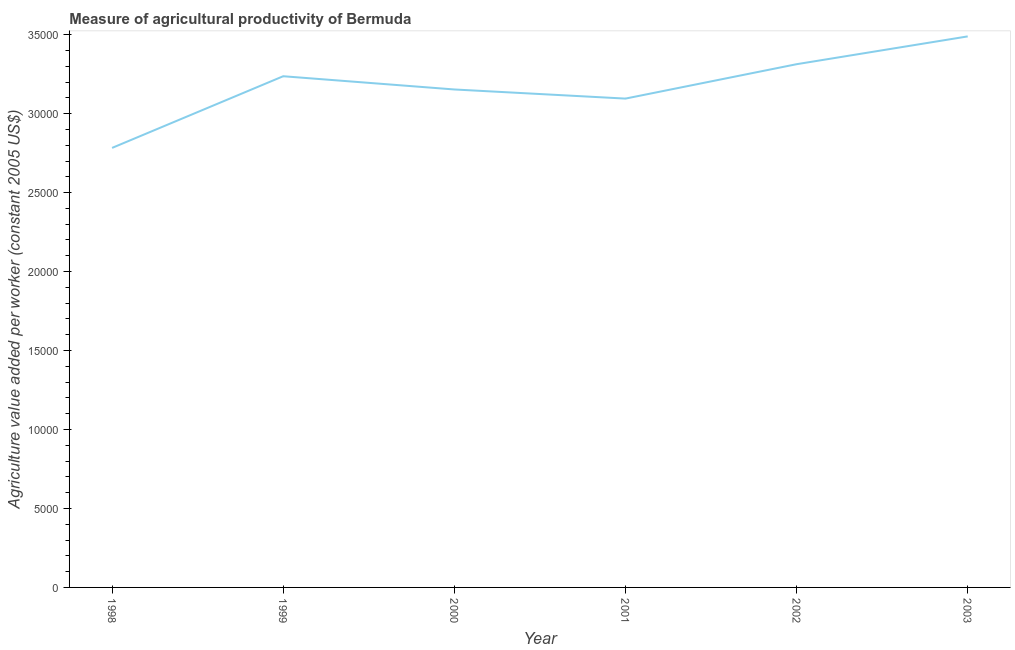What is the agriculture value added per worker in 1998?
Offer a terse response. 2.78e+04. Across all years, what is the maximum agriculture value added per worker?
Your answer should be compact. 3.49e+04. Across all years, what is the minimum agriculture value added per worker?
Your answer should be compact. 2.78e+04. In which year was the agriculture value added per worker maximum?
Your response must be concise. 2003. In which year was the agriculture value added per worker minimum?
Make the answer very short. 1998. What is the sum of the agriculture value added per worker?
Your response must be concise. 1.91e+05. What is the difference between the agriculture value added per worker in 1999 and 2002?
Ensure brevity in your answer.  -762.28. What is the average agriculture value added per worker per year?
Your answer should be compact. 3.18e+04. What is the median agriculture value added per worker?
Provide a succinct answer. 3.20e+04. What is the ratio of the agriculture value added per worker in 1998 to that in 2002?
Offer a very short reply. 0.84. What is the difference between the highest and the second highest agriculture value added per worker?
Make the answer very short. 1760.39. Is the sum of the agriculture value added per worker in 2000 and 2003 greater than the maximum agriculture value added per worker across all years?
Your answer should be compact. Yes. What is the difference between the highest and the lowest agriculture value added per worker?
Keep it short and to the point. 7060.72. Does the agriculture value added per worker monotonically increase over the years?
Keep it short and to the point. No. What is the difference between two consecutive major ticks on the Y-axis?
Offer a very short reply. 5000. Are the values on the major ticks of Y-axis written in scientific E-notation?
Make the answer very short. No. Does the graph contain any zero values?
Provide a succinct answer. No. Does the graph contain grids?
Make the answer very short. No. What is the title of the graph?
Ensure brevity in your answer.  Measure of agricultural productivity of Bermuda. What is the label or title of the Y-axis?
Keep it short and to the point. Agriculture value added per worker (constant 2005 US$). What is the Agriculture value added per worker (constant 2005 US$) in 1998?
Keep it short and to the point. 2.78e+04. What is the Agriculture value added per worker (constant 2005 US$) in 1999?
Offer a terse response. 3.24e+04. What is the Agriculture value added per worker (constant 2005 US$) of 2000?
Provide a short and direct response. 3.15e+04. What is the Agriculture value added per worker (constant 2005 US$) in 2001?
Provide a short and direct response. 3.10e+04. What is the Agriculture value added per worker (constant 2005 US$) in 2002?
Your response must be concise. 3.31e+04. What is the Agriculture value added per worker (constant 2005 US$) in 2003?
Your answer should be very brief. 3.49e+04. What is the difference between the Agriculture value added per worker (constant 2005 US$) in 1998 and 1999?
Ensure brevity in your answer.  -4538.04. What is the difference between the Agriculture value added per worker (constant 2005 US$) in 1998 and 2000?
Keep it short and to the point. -3700.06. What is the difference between the Agriculture value added per worker (constant 2005 US$) in 1998 and 2001?
Offer a terse response. -3122.71. What is the difference between the Agriculture value added per worker (constant 2005 US$) in 1998 and 2002?
Make the answer very short. -5300.33. What is the difference between the Agriculture value added per worker (constant 2005 US$) in 1998 and 2003?
Give a very brief answer. -7060.72. What is the difference between the Agriculture value added per worker (constant 2005 US$) in 1999 and 2000?
Give a very brief answer. 837.99. What is the difference between the Agriculture value added per worker (constant 2005 US$) in 1999 and 2001?
Offer a terse response. 1415.33. What is the difference between the Agriculture value added per worker (constant 2005 US$) in 1999 and 2002?
Your response must be concise. -762.28. What is the difference between the Agriculture value added per worker (constant 2005 US$) in 1999 and 2003?
Keep it short and to the point. -2522.67. What is the difference between the Agriculture value added per worker (constant 2005 US$) in 2000 and 2001?
Your answer should be compact. 577.34. What is the difference between the Agriculture value added per worker (constant 2005 US$) in 2000 and 2002?
Ensure brevity in your answer.  -1600.27. What is the difference between the Agriculture value added per worker (constant 2005 US$) in 2000 and 2003?
Your answer should be compact. -3360.66. What is the difference between the Agriculture value added per worker (constant 2005 US$) in 2001 and 2002?
Give a very brief answer. -2177.61. What is the difference between the Agriculture value added per worker (constant 2005 US$) in 2001 and 2003?
Offer a terse response. -3938. What is the difference between the Agriculture value added per worker (constant 2005 US$) in 2002 and 2003?
Ensure brevity in your answer.  -1760.39. What is the ratio of the Agriculture value added per worker (constant 2005 US$) in 1998 to that in 1999?
Offer a very short reply. 0.86. What is the ratio of the Agriculture value added per worker (constant 2005 US$) in 1998 to that in 2000?
Your response must be concise. 0.88. What is the ratio of the Agriculture value added per worker (constant 2005 US$) in 1998 to that in 2001?
Your answer should be very brief. 0.9. What is the ratio of the Agriculture value added per worker (constant 2005 US$) in 1998 to that in 2002?
Offer a terse response. 0.84. What is the ratio of the Agriculture value added per worker (constant 2005 US$) in 1998 to that in 2003?
Provide a succinct answer. 0.8. What is the ratio of the Agriculture value added per worker (constant 2005 US$) in 1999 to that in 2000?
Provide a succinct answer. 1.03. What is the ratio of the Agriculture value added per worker (constant 2005 US$) in 1999 to that in 2001?
Your response must be concise. 1.05. What is the ratio of the Agriculture value added per worker (constant 2005 US$) in 1999 to that in 2003?
Make the answer very short. 0.93. What is the ratio of the Agriculture value added per worker (constant 2005 US$) in 2000 to that in 2003?
Provide a short and direct response. 0.9. What is the ratio of the Agriculture value added per worker (constant 2005 US$) in 2001 to that in 2002?
Give a very brief answer. 0.93. What is the ratio of the Agriculture value added per worker (constant 2005 US$) in 2001 to that in 2003?
Provide a succinct answer. 0.89. What is the ratio of the Agriculture value added per worker (constant 2005 US$) in 2002 to that in 2003?
Make the answer very short. 0.95. 